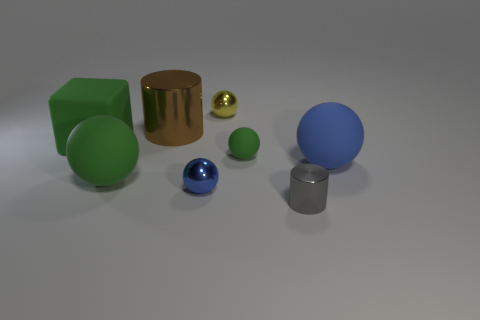What can you infer about the light source in this image? The shadows cast by the objects point towards a light source that is off to the right and somewhat above the scene. The reflections and highlights on the objects, particularly on the gold cylinder and spheres, suggest the light is relatively strong and possibly a single source like a spotlight. Is there any indication of what time of day it might be or if we are indoors? Given that the background is nondescript and there is no natural scenery to provide context, it is not possible to accurately determine the time of day. However, the controlled lighting and shadow consistency indicate that we are likely viewing an indoor set-up, possibly in a studio or a controlled environment for photography or rendering. 